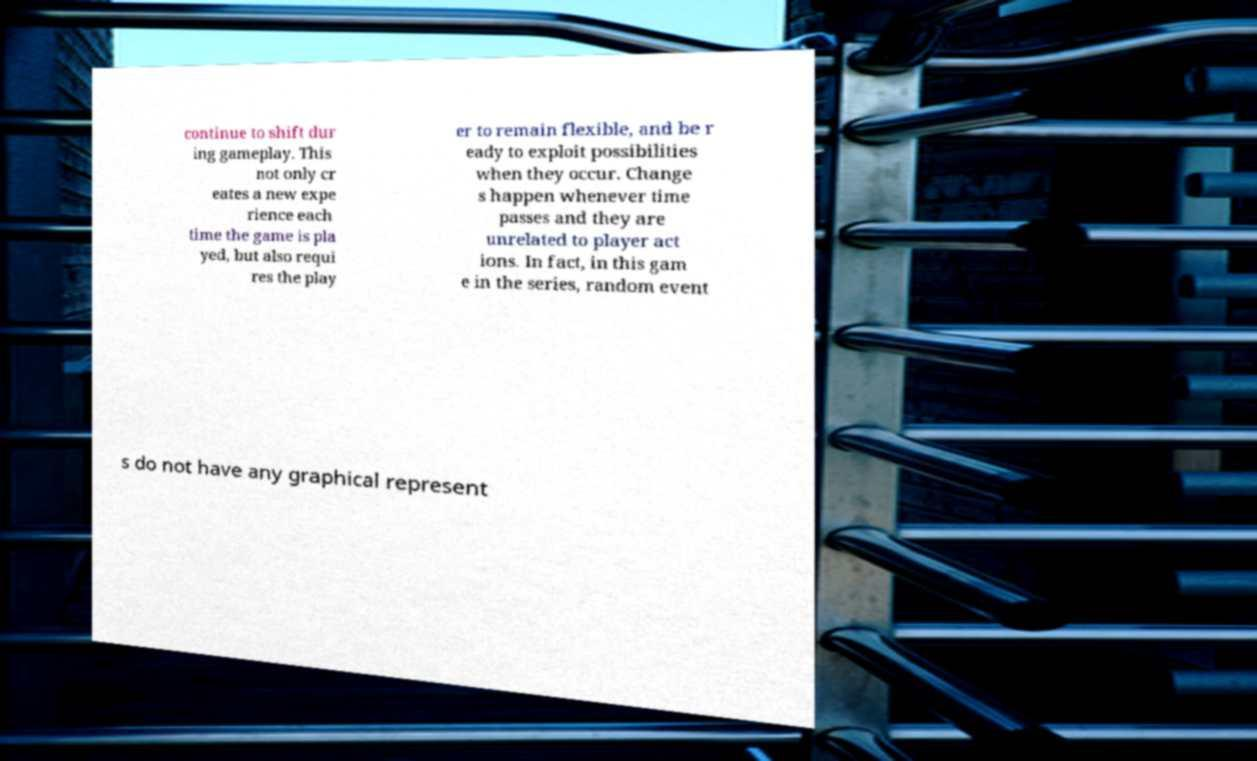I need the written content from this picture converted into text. Can you do that? continue to shift dur ing gameplay. This not only cr eates a new expe rience each time the game is pla yed, but also requi res the play er to remain flexible, and be r eady to exploit possibilities when they occur. Change s happen whenever time passes and they are unrelated to player act ions. In fact, in this gam e in the series, random event s do not have any graphical represent 